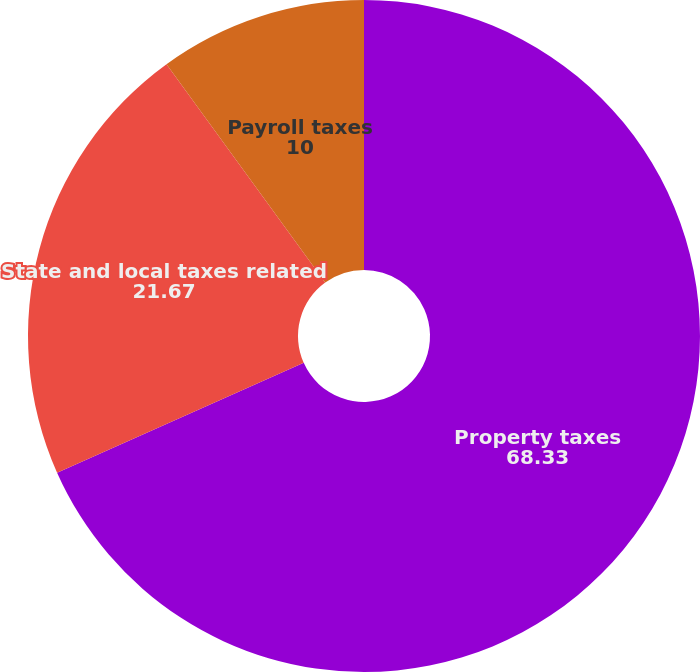Convert chart. <chart><loc_0><loc_0><loc_500><loc_500><pie_chart><fcel>Property taxes<fcel>State and local taxes related<fcel>Payroll taxes<nl><fcel>68.33%<fcel>21.67%<fcel>10.0%<nl></chart> 